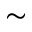Convert formula to latex. <formula><loc_0><loc_0><loc_500><loc_500>\sim</formula> 